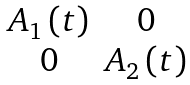<formula> <loc_0><loc_0><loc_500><loc_500>\begin{matrix} A _ { 1 } \left ( t \right ) & 0 \\ 0 & A _ { 2 } \left ( t \right ) \\ \end{matrix}</formula> 